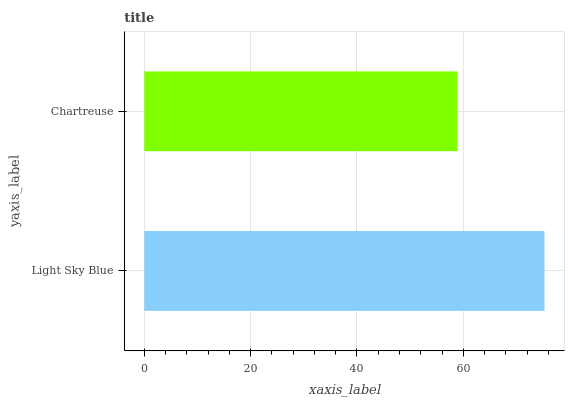Is Chartreuse the minimum?
Answer yes or no. Yes. Is Light Sky Blue the maximum?
Answer yes or no. Yes. Is Chartreuse the maximum?
Answer yes or no. No. Is Light Sky Blue greater than Chartreuse?
Answer yes or no. Yes. Is Chartreuse less than Light Sky Blue?
Answer yes or no. Yes. Is Chartreuse greater than Light Sky Blue?
Answer yes or no. No. Is Light Sky Blue less than Chartreuse?
Answer yes or no. No. Is Light Sky Blue the high median?
Answer yes or no. Yes. Is Chartreuse the low median?
Answer yes or no. Yes. Is Chartreuse the high median?
Answer yes or no. No. Is Light Sky Blue the low median?
Answer yes or no. No. 